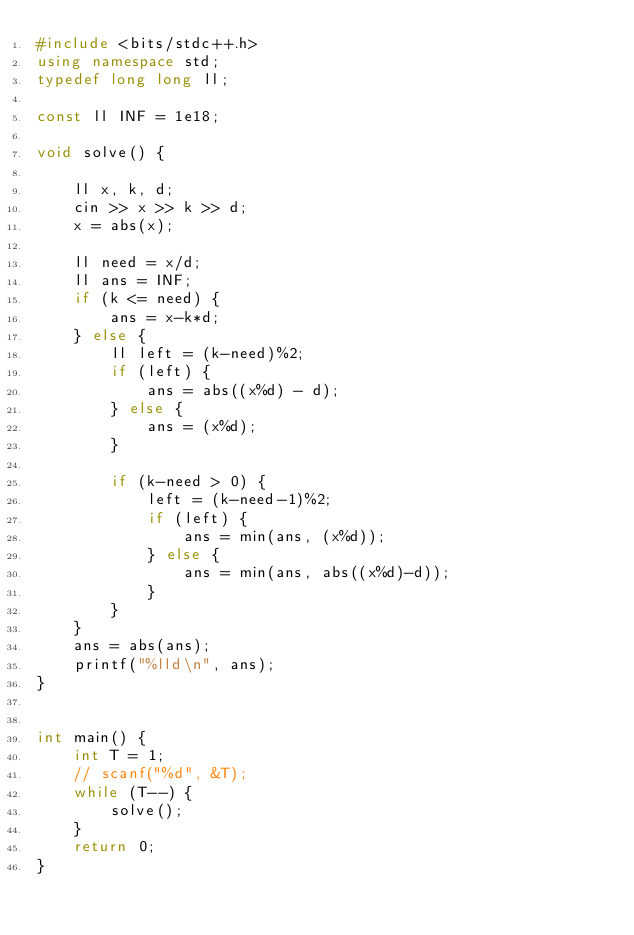<code> <loc_0><loc_0><loc_500><loc_500><_C++_>#include <bits/stdc++.h>
using namespace std;
typedef long long ll;

const ll INF = 1e18;

void solve() {

    ll x, k, d;
    cin >> x >> k >> d;
    x = abs(x);

    ll need = x/d;
    ll ans = INF;
    if (k <= need) {
        ans = x-k*d;
    } else {
        ll left = (k-need)%2;
        if (left) {
            ans = abs((x%d) - d);
        } else {
            ans = (x%d);
        }

        if (k-need > 0) {
            left = (k-need-1)%2;
            if (left) {
                ans = min(ans, (x%d));
            } else {
                ans = min(ans, abs((x%d)-d));
            }
        }
    }
    ans = abs(ans);
    printf("%lld\n", ans);
}


int main() {
    int T = 1;
    // scanf("%d", &T);
    while (T--) {
        solve();
    }
    return 0;
}
</code> 